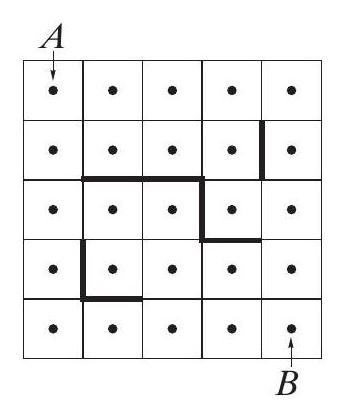If an additional row of obstacles were added, how would that impact the number of possible paths from A to B? Adding an additional row of obstacles would generally decrease the number of available paths from A to B, as more routes would be blocked. The impact would depend on the location of this new row. If it blocks critical junctions or pathways, it could significantly limit the routing options, potentially even isolating B making it unreachable from A depending on the grid's configuration. 